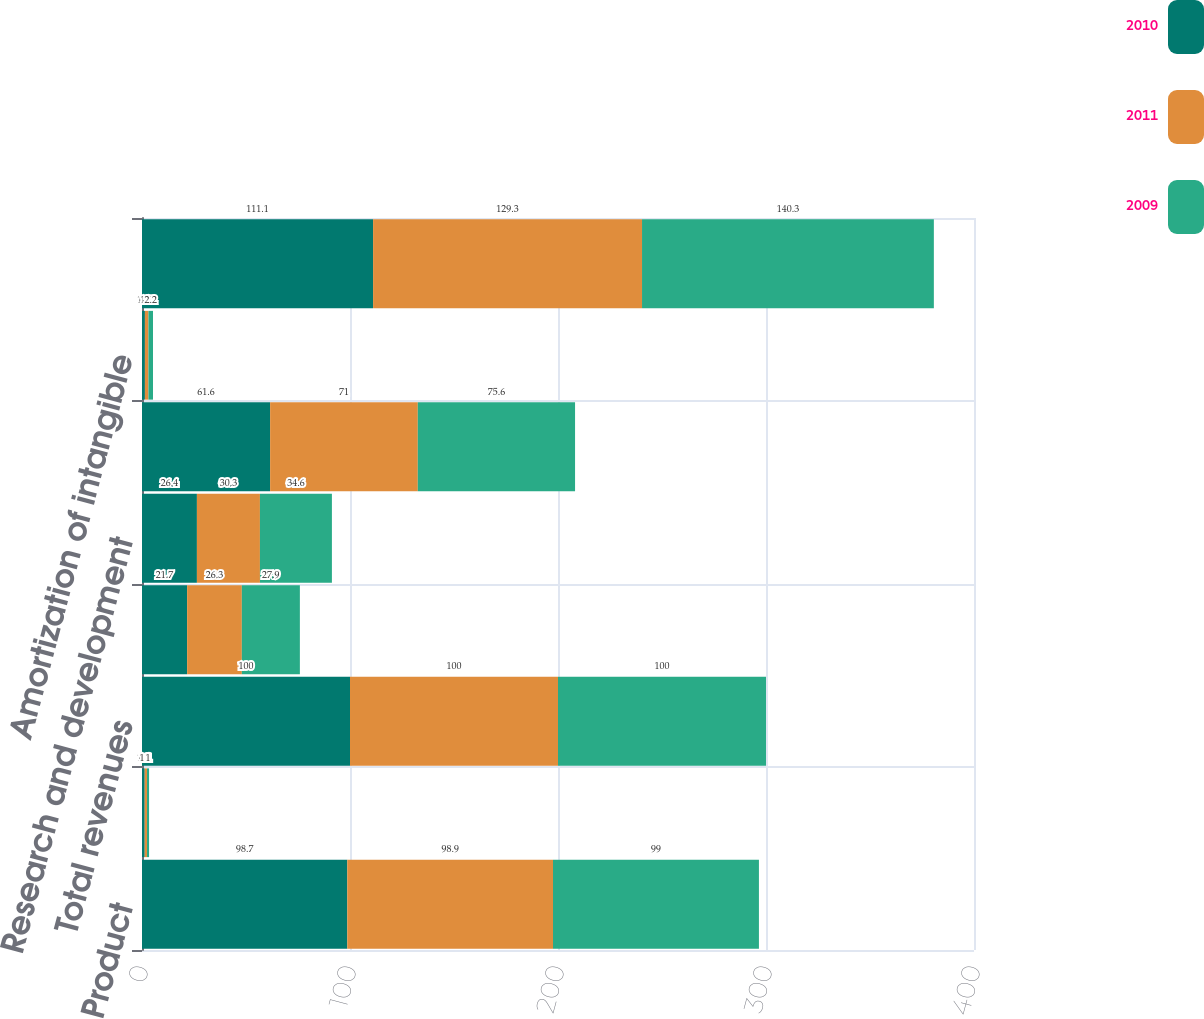Convert chart. <chart><loc_0><loc_0><loc_500><loc_500><stacked_bar_chart><ecel><fcel>Product<fcel>Funded research and<fcel>Total revenues<fcel>Cost of product revenue<fcel>Research and development<fcel>Selling general and<fcel>Amortization of intangible<fcel>Total costs and expenses<nl><fcel>2010<fcel>98.7<fcel>1.3<fcel>100<fcel>21.7<fcel>26.4<fcel>61.6<fcel>1.4<fcel>111.1<nl><fcel>2011<fcel>98.9<fcel>1.1<fcel>100<fcel>26.3<fcel>30.3<fcel>71<fcel>1.7<fcel>129.3<nl><fcel>2009<fcel>99<fcel>1<fcel>100<fcel>27.9<fcel>34.6<fcel>75.6<fcel>2.2<fcel>140.3<nl></chart> 